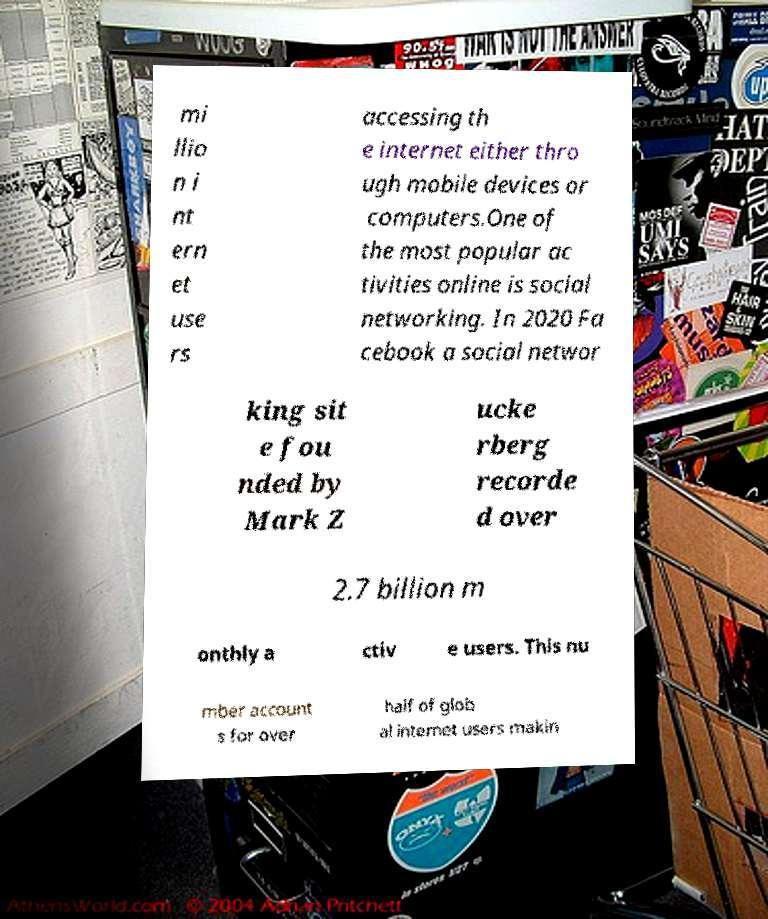Please read and relay the text visible in this image. What does it say? mi llio n i nt ern et use rs accessing th e internet either thro ugh mobile devices or computers.One of the most popular ac tivities online is social networking. In 2020 Fa cebook a social networ king sit e fou nded by Mark Z ucke rberg recorde d over 2.7 billion m onthly a ctiv e users. This nu mber account s for over half of glob al internet users makin 